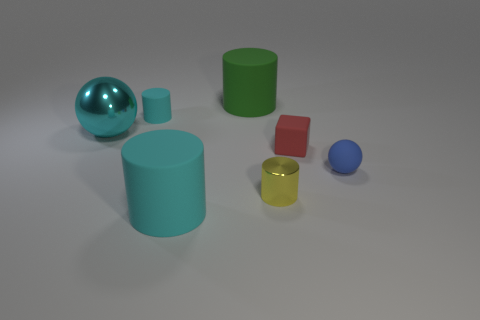Subtract all matte cylinders. How many cylinders are left? 1 Add 1 blue rubber spheres. How many objects exist? 8 Subtract all red cylinders. Subtract all green blocks. How many cylinders are left? 4 Subtract all cylinders. How many objects are left? 3 Subtract all tiny green matte cylinders. Subtract all large green matte things. How many objects are left? 6 Add 6 large cyan matte cylinders. How many large cyan matte cylinders are left? 7 Add 6 tiny yellow matte objects. How many tiny yellow matte objects exist? 6 Subtract 0 purple spheres. How many objects are left? 7 